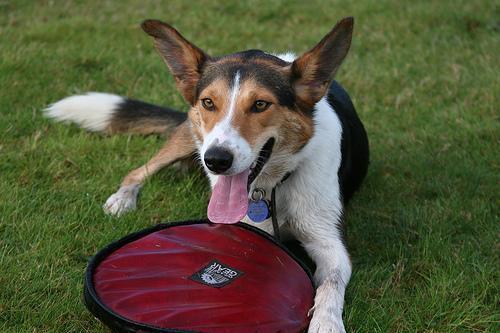How many dogs are there?
Give a very brief answer. 1. 